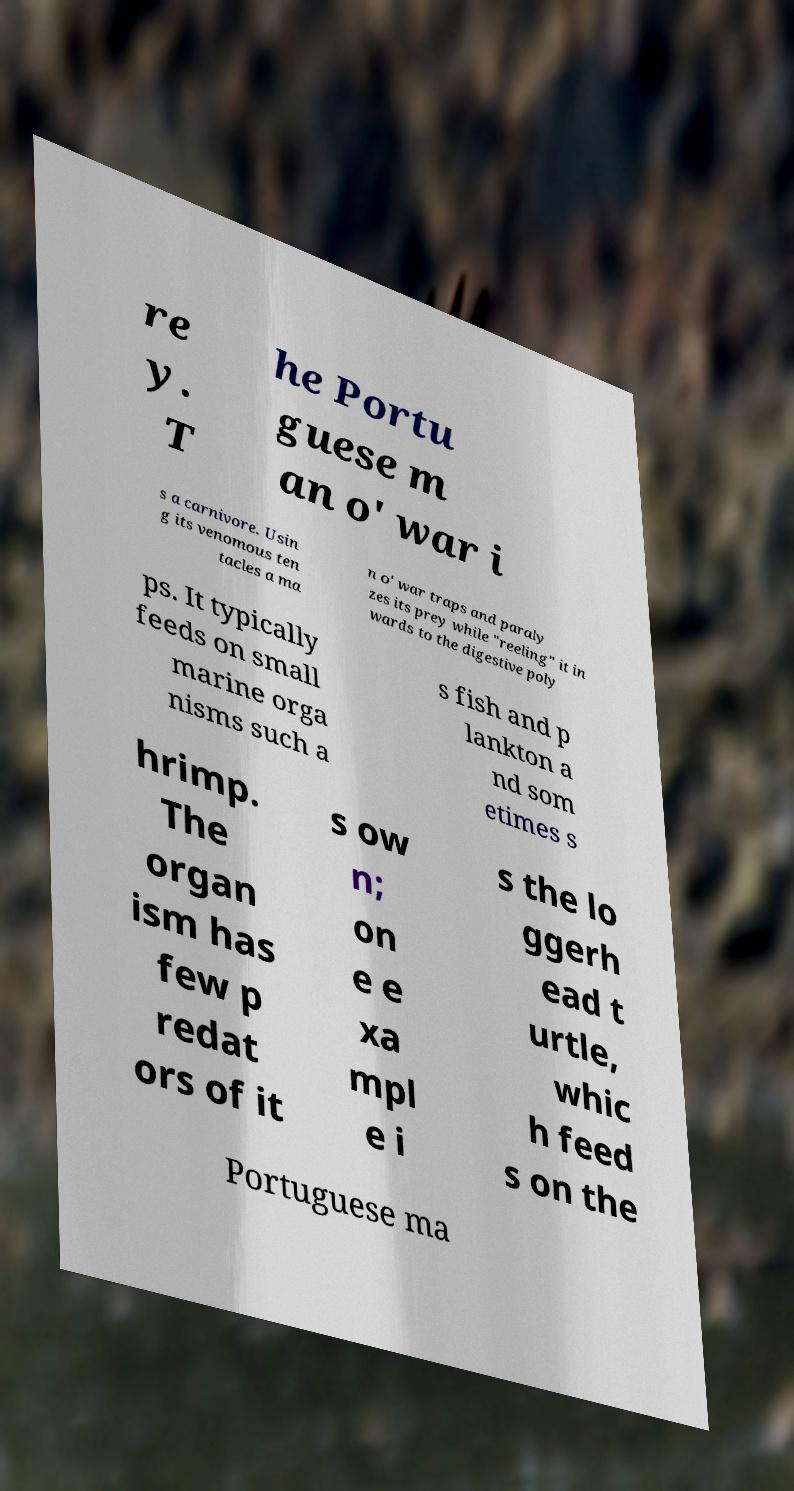I need the written content from this picture converted into text. Can you do that? re y. T he Portu guese m an o' war i s a carnivore. Usin g its venomous ten tacles a ma n o' war traps and paraly zes its prey while "reeling" it in wards to the digestive poly ps. It typically feeds on small marine orga nisms such a s fish and p lankton a nd som etimes s hrimp. The organ ism has few p redat ors of it s ow n; on e e xa mpl e i s the lo ggerh ead t urtle, whic h feed s on the Portuguese ma 